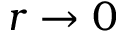<formula> <loc_0><loc_0><loc_500><loc_500>r \rightarrow 0</formula> 